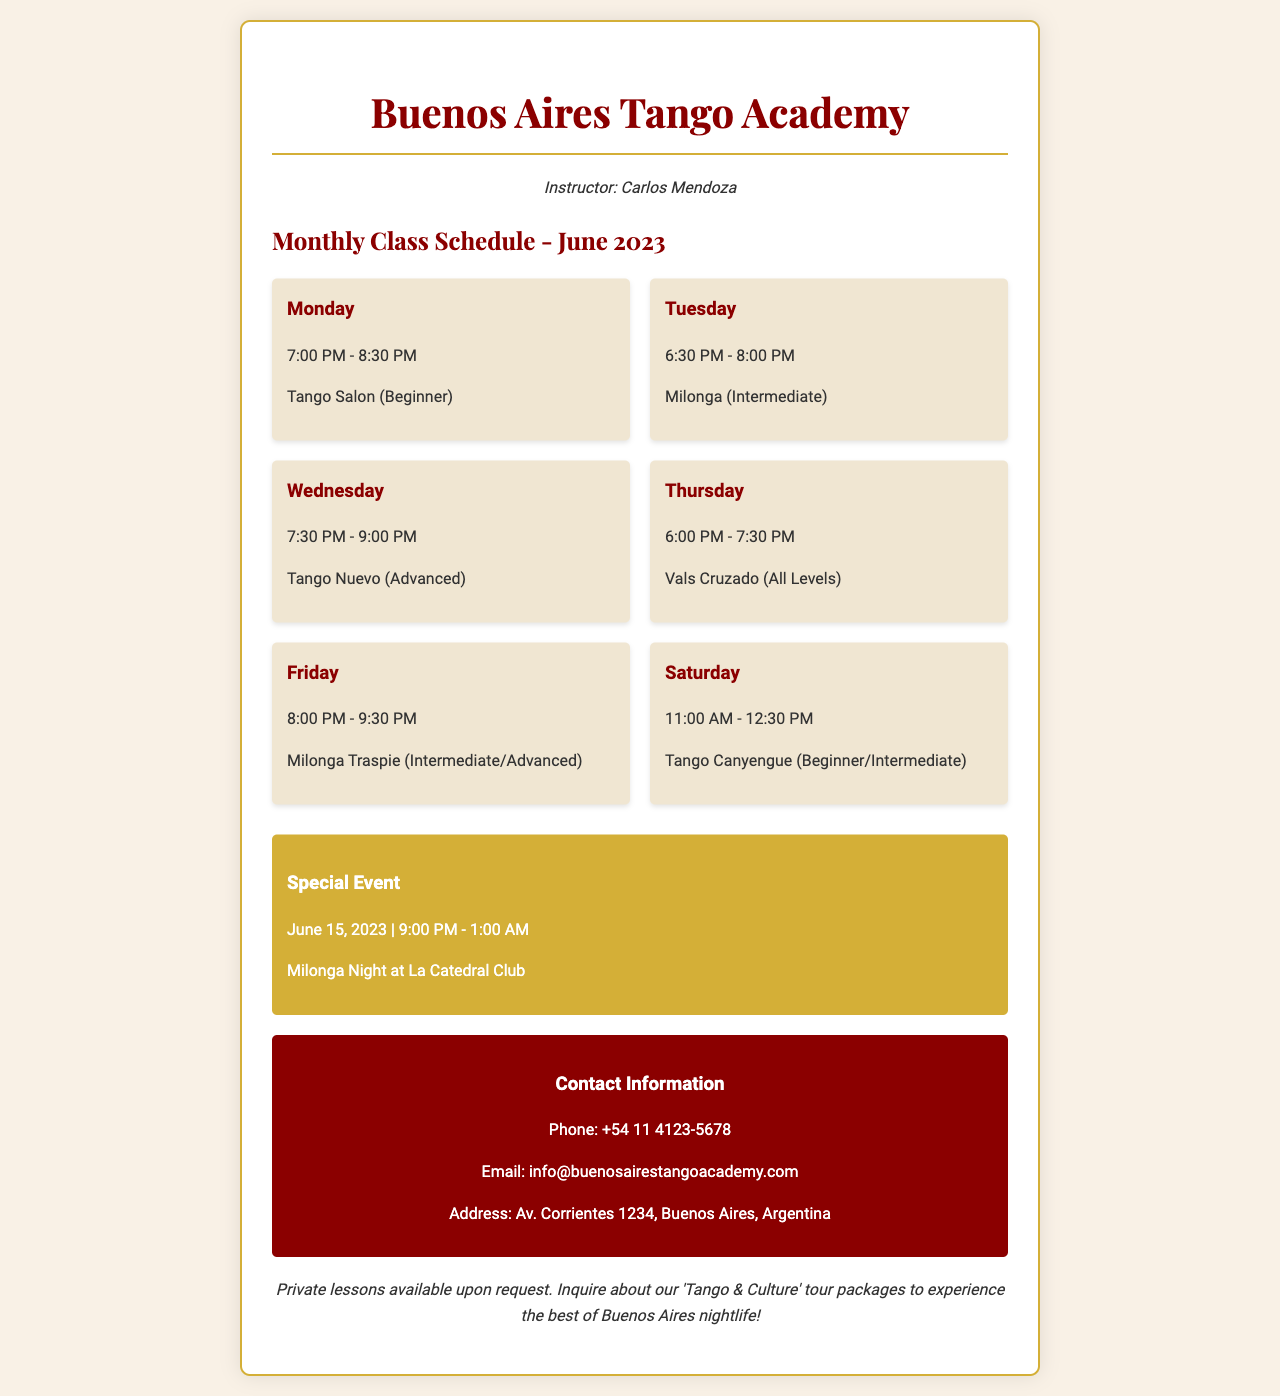What day and time is the Tango Salon class? The Tango Salon class is scheduled for Monday from 7:00 PM to 8:30 PM.
Answer: Monday, 7:00 PM - 8:30 PM How many levels are there for the Vals Cruzado class? The Vals Cruzado class is listed as suitable for all levels, indicating there is no specific level restriction.
Answer: All Levels What is the date of the special event? The special event is on June 15, 2023.
Answer: June 15, 2023 Which class occurs on Friday? The class on Friday is titled Milonga Traspie.
Answer: Milonga Traspie What is the instructor's name? The instructor's name listed at the top of the document is Carlos Mendoza.
Answer: Carlos Mendoza What is the contact phone number for the academy? The contact phone number provided is +54 11 4123-5678.
Answer: +54 11 4123-5678 How long does the Milonga Night Special Event last? The Milonga Night event is scheduled to last for 4 hours, from 9:00 PM to 1:00 AM.
Answer: 4 hours How many classes are there in total for the month? There are a total of 6 regular classes scheduled throughout the week.
Answer: 6 classes What is available upon request according to the note at the end? The document states that private lessons are available upon request.
Answer: Private lessons 